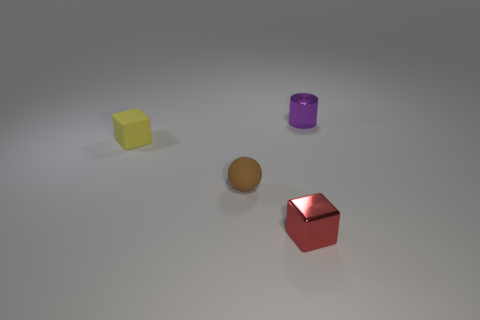How many things are small red things or small things?
Provide a succinct answer. 4. There is a tiny red shiny object; what shape is it?
Your answer should be compact. Cube. What is the shape of the thing to the right of the small metallic thing in front of the purple metallic cylinder?
Offer a very short reply. Cylinder. Is the block to the right of the tiny yellow thing made of the same material as the brown sphere?
Your response must be concise. No. What number of red things are small metallic things or rubber cubes?
Your answer should be compact. 1. Is there a ball that has the same material as the tiny red object?
Keep it short and to the point. No. The tiny thing that is both behind the small brown object and to the left of the shiny cube has what shape?
Your answer should be very brief. Cube. What number of big things are green rubber cylinders or metallic cubes?
Keep it short and to the point. 0. What is the ball made of?
Keep it short and to the point. Rubber. What number of other objects are there of the same shape as the red shiny object?
Your answer should be very brief. 1. 